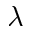<formula> <loc_0><loc_0><loc_500><loc_500>\lambda</formula> 